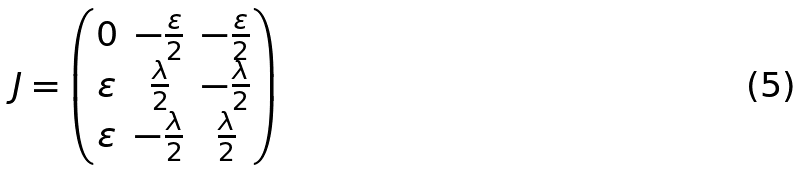Convert formula to latex. <formula><loc_0><loc_0><loc_500><loc_500>J = \begin{pmatrix} 0 & - \frac { \varepsilon } { 2 } & - \frac { \varepsilon } { 2 } \\ \varepsilon & \frac { \lambda } { 2 } & - \frac { \lambda } { 2 } \\ \varepsilon & - \frac { \lambda } { 2 } & \frac { \lambda } { 2 } \end{pmatrix}</formula> 